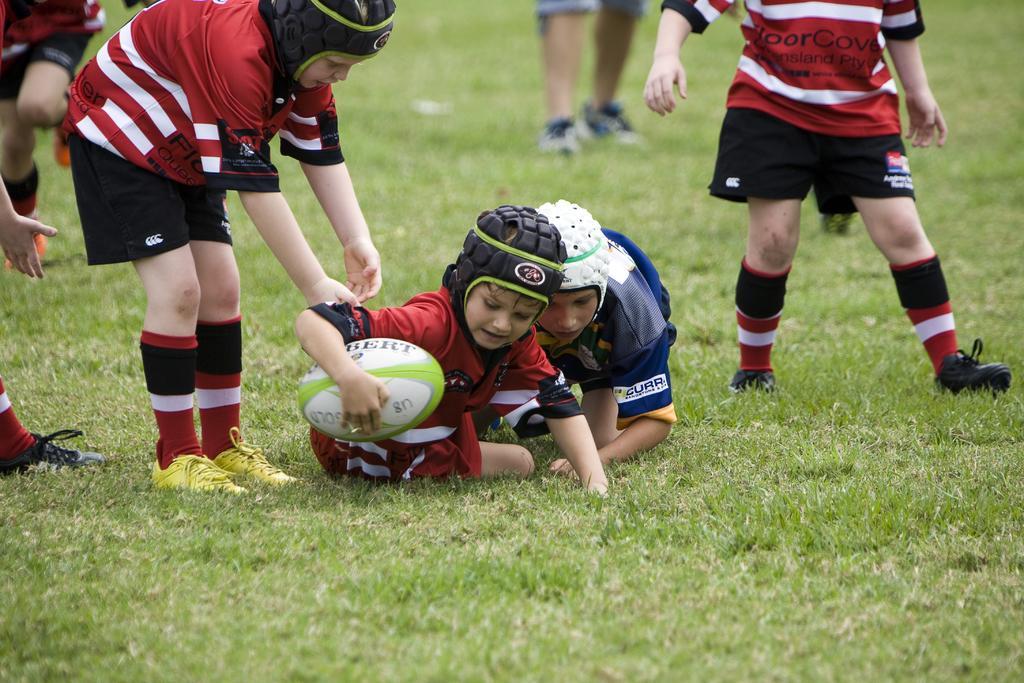How would you summarize this image in a sentence or two? Here in this picture we can see number of children present on the ground, which is fully covered with grass and they are wearing helmets and the child in the middle is holding a rugby ball in his hand. 